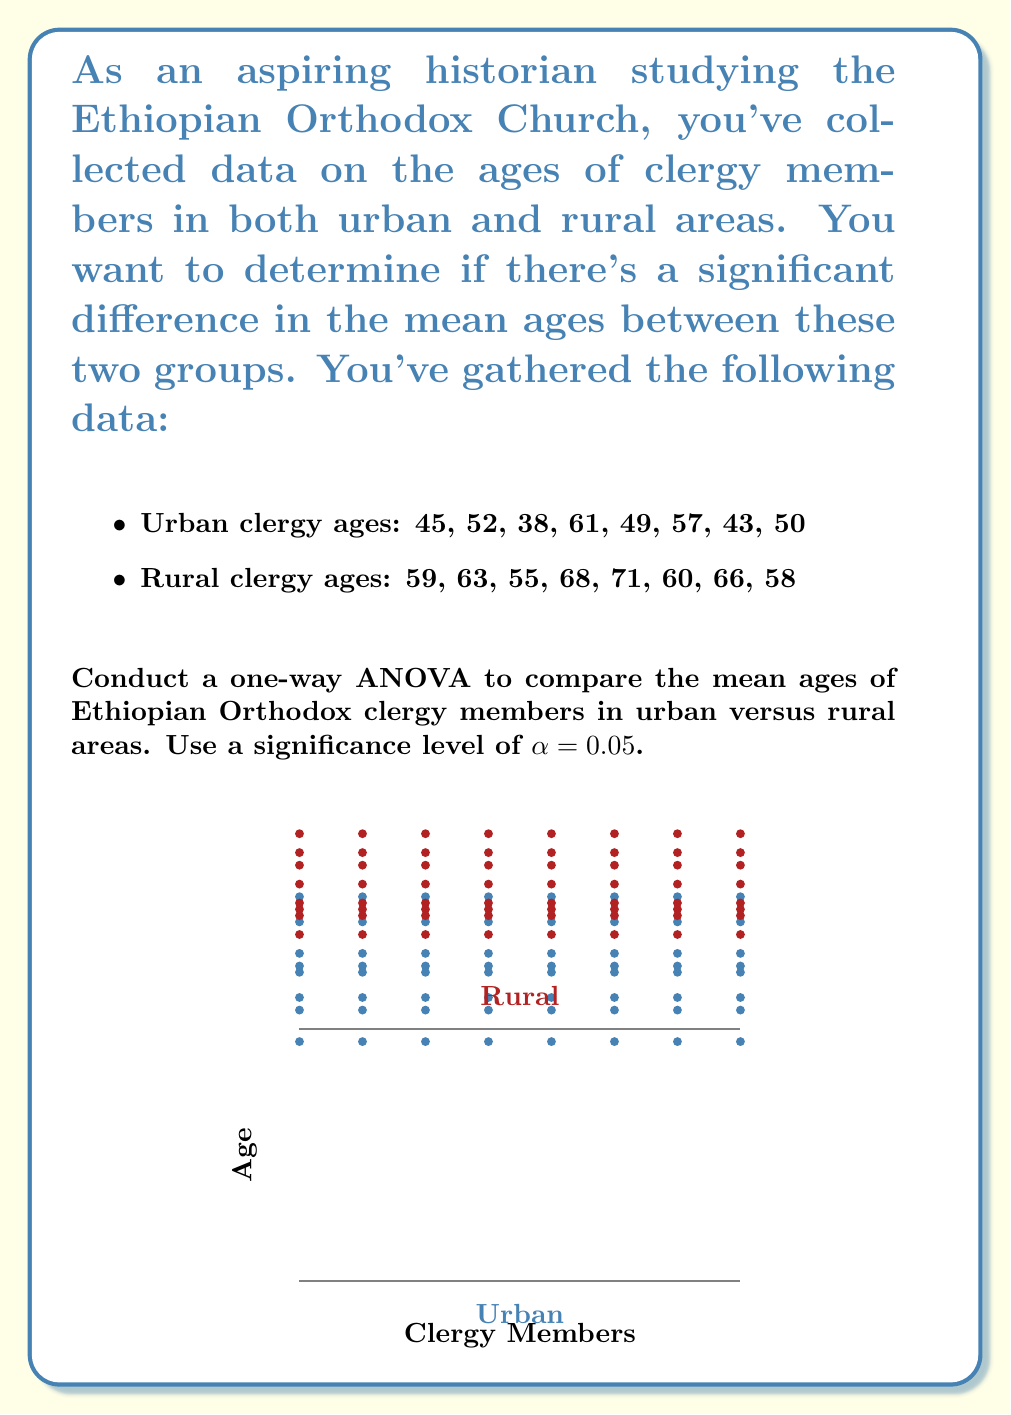What is the answer to this math problem? To conduct a one-way ANOVA, we'll follow these steps:

1. Calculate the sum of squares between groups (SSB) and within groups (SSW).
2. Calculate the degrees of freedom for between groups (dfB) and within groups (dfW).
3. Calculate the mean squares between groups (MSB) and within groups (MSW).
4. Calculate the F-statistic.
5. Compare the F-statistic to the critical F-value.

Step 1: Calculate SSB and SSW

First, we need to calculate the grand mean and group means:

Grand mean: $\bar{X} = \frac{(45+52+38+61+49+57+43+50+59+63+55+68+71+60+66+58)}{16} = 55.9375$

Urban mean: $\bar{X}_U = \frac{(45+52+38+61+49+57+43+50)}{8} = 49.375$
Rural mean: $\bar{X}_R = \frac{(59+63+55+68+71+60+66+58)}{8} = 62.5$

SSB = $n_1(\bar{X}_U - \bar{X})^2 + n_2(\bar{X}_R - \bar{X})^2$
    = $8(49.375 - 55.9375)^2 + 8(62.5 - 55.9375)^2$
    = $8(42.9140625) + 8(42.9140625)$
    = $686.625$

SSW = $\sum_{i=1}^{8} (X_{Ui} - \bar{X}_U)^2 + \sum_{i=1}^{8} (X_{Ri} - \bar{X}_R)^2$
    = $[(45-49.375)^2 + ... + (50-49.375)^2] + [(59-62.5)^2 + ... + (58-62.5)^2]$
    = $430.875 + 258.0$
    = $688.875$

Step 2: Calculate degrees of freedom

dfB = number of groups - 1 = 2 - 1 = 1
dfW = total number of observations - number of groups = 16 - 2 = 14

Step 3: Calculate mean squares

MSB = SSB / dfB = 686.625 / 1 = 686.625
MSW = SSW / dfW = 688.875 / 14 = 49.205357

Step 4: Calculate F-statistic

F = MSB / MSW = 686.625 / 49.205357 = 13.95447

Step 5: Compare F-statistic to critical F-value

The critical F-value for α = 0.05, dfB = 1, and dfW = 14 is approximately 4.60.

Since our calculated F-statistic (13.95447) is greater than the critical F-value (4.60), we reject the null hypothesis.
Answer: F(1,14) = 13.95, p < 0.05. Significant difference in mean ages between urban and rural clergy. 